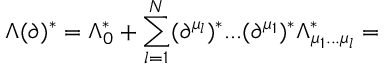<formula> <loc_0><loc_0><loc_500><loc_500>\Lambda ( \partial ) ^ { * } = \Lambda _ { 0 } ^ { * } + \sum _ { l = 1 } ^ { N } ( \partial ^ { \mu _ { l } } ) ^ { * } \dots ( \partial ^ { \mu _ { 1 } } ) ^ { * } \Lambda _ { \mu _ { 1 } \dots \mu _ { l } } ^ { * } =</formula> 